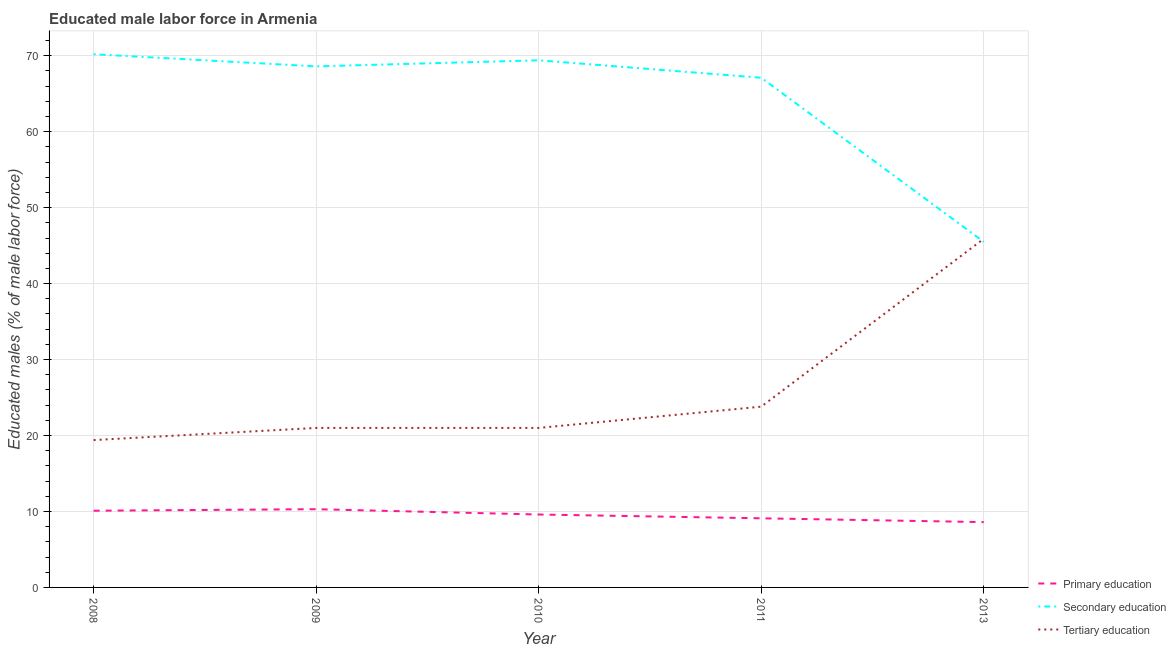What is the percentage of male labor force who received tertiary education in 2008?
Provide a short and direct response. 19.4. Across all years, what is the maximum percentage of male labor force who received tertiary education?
Keep it short and to the point. 45.9. Across all years, what is the minimum percentage of male labor force who received secondary education?
Keep it short and to the point. 45.5. What is the total percentage of male labor force who received tertiary education in the graph?
Give a very brief answer. 131.1. What is the difference between the percentage of male labor force who received secondary education in 2009 and that in 2013?
Your answer should be very brief. 23.1. What is the difference between the percentage of male labor force who received secondary education in 2010 and the percentage of male labor force who received tertiary education in 2009?
Offer a very short reply. 48.4. What is the average percentage of male labor force who received primary education per year?
Your response must be concise. 9.54. In the year 2010, what is the difference between the percentage of male labor force who received tertiary education and percentage of male labor force who received secondary education?
Your answer should be very brief. -48.4. In how many years, is the percentage of male labor force who received tertiary education greater than 16 %?
Ensure brevity in your answer.  5. What is the ratio of the percentage of male labor force who received tertiary education in 2008 to that in 2009?
Make the answer very short. 0.92. Is the percentage of male labor force who received secondary education in 2008 less than that in 2011?
Offer a terse response. No. What is the difference between the highest and the second highest percentage of male labor force who received primary education?
Ensure brevity in your answer.  0.2. What is the difference between the highest and the lowest percentage of male labor force who received secondary education?
Make the answer very short. 24.7. Is it the case that in every year, the sum of the percentage of male labor force who received primary education and percentage of male labor force who received secondary education is greater than the percentage of male labor force who received tertiary education?
Ensure brevity in your answer.  Yes. Does the percentage of male labor force who received tertiary education monotonically increase over the years?
Offer a terse response. No. What is the difference between two consecutive major ticks on the Y-axis?
Your response must be concise. 10. Are the values on the major ticks of Y-axis written in scientific E-notation?
Ensure brevity in your answer.  No. Where does the legend appear in the graph?
Offer a very short reply. Bottom right. How many legend labels are there?
Keep it short and to the point. 3. What is the title of the graph?
Make the answer very short. Educated male labor force in Armenia. Does "Central government" appear as one of the legend labels in the graph?
Your response must be concise. No. What is the label or title of the Y-axis?
Offer a terse response. Educated males (% of male labor force). What is the Educated males (% of male labor force) of Primary education in 2008?
Your answer should be very brief. 10.1. What is the Educated males (% of male labor force) in Secondary education in 2008?
Offer a terse response. 70.2. What is the Educated males (% of male labor force) of Tertiary education in 2008?
Ensure brevity in your answer.  19.4. What is the Educated males (% of male labor force) in Primary education in 2009?
Offer a very short reply. 10.3. What is the Educated males (% of male labor force) of Secondary education in 2009?
Make the answer very short. 68.6. What is the Educated males (% of male labor force) in Tertiary education in 2009?
Give a very brief answer. 21. What is the Educated males (% of male labor force) in Primary education in 2010?
Provide a short and direct response. 9.6. What is the Educated males (% of male labor force) in Secondary education in 2010?
Provide a succinct answer. 69.4. What is the Educated males (% of male labor force) in Primary education in 2011?
Your answer should be very brief. 9.1. What is the Educated males (% of male labor force) in Secondary education in 2011?
Provide a succinct answer. 67.1. What is the Educated males (% of male labor force) of Tertiary education in 2011?
Provide a short and direct response. 23.8. What is the Educated males (% of male labor force) of Primary education in 2013?
Provide a short and direct response. 8.6. What is the Educated males (% of male labor force) in Secondary education in 2013?
Keep it short and to the point. 45.5. What is the Educated males (% of male labor force) in Tertiary education in 2013?
Ensure brevity in your answer.  45.9. Across all years, what is the maximum Educated males (% of male labor force) in Primary education?
Make the answer very short. 10.3. Across all years, what is the maximum Educated males (% of male labor force) in Secondary education?
Keep it short and to the point. 70.2. Across all years, what is the maximum Educated males (% of male labor force) in Tertiary education?
Offer a very short reply. 45.9. Across all years, what is the minimum Educated males (% of male labor force) of Primary education?
Your answer should be compact. 8.6. Across all years, what is the minimum Educated males (% of male labor force) in Secondary education?
Offer a terse response. 45.5. Across all years, what is the minimum Educated males (% of male labor force) of Tertiary education?
Offer a terse response. 19.4. What is the total Educated males (% of male labor force) of Primary education in the graph?
Keep it short and to the point. 47.7. What is the total Educated males (% of male labor force) of Secondary education in the graph?
Ensure brevity in your answer.  320.8. What is the total Educated males (% of male labor force) in Tertiary education in the graph?
Offer a very short reply. 131.1. What is the difference between the Educated males (% of male labor force) in Secondary education in 2008 and that in 2010?
Keep it short and to the point. 0.8. What is the difference between the Educated males (% of male labor force) of Tertiary education in 2008 and that in 2010?
Make the answer very short. -1.6. What is the difference between the Educated males (% of male labor force) of Primary education in 2008 and that in 2011?
Your answer should be compact. 1. What is the difference between the Educated males (% of male labor force) in Secondary education in 2008 and that in 2011?
Make the answer very short. 3.1. What is the difference between the Educated males (% of male labor force) of Primary education in 2008 and that in 2013?
Your response must be concise. 1.5. What is the difference between the Educated males (% of male labor force) in Secondary education in 2008 and that in 2013?
Offer a terse response. 24.7. What is the difference between the Educated males (% of male labor force) in Tertiary education in 2008 and that in 2013?
Make the answer very short. -26.5. What is the difference between the Educated males (% of male labor force) in Primary education in 2009 and that in 2010?
Provide a short and direct response. 0.7. What is the difference between the Educated males (% of male labor force) in Secondary education in 2009 and that in 2010?
Offer a very short reply. -0.8. What is the difference between the Educated males (% of male labor force) in Primary education in 2009 and that in 2011?
Offer a terse response. 1.2. What is the difference between the Educated males (% of male labor force) of Secondary education in 2009 and that in 2011?
Provide a succinct answer. 1.5. What is the difference between the Educated males (% of male labor force) in Secondary education in 2009 and that in 2013?
Your answer should be very brief. 23.1. What is the difference between the Educated males (% of male labor force) of Tertiary education in 2009 and that in 2013?
Offer a terse response. -24.9. What is the difference between the Educated males (% of male labor force) in Primary education in 2010 and that in 2011?
Keep it short and to the point. 0.5. What is the difference between the Educated males (% of male labor force) in Primary education in 2010 and that in 2013?
Your response must be concise. 1. What is the difference between the Educated males (% of male labor force) of Secondary education in 2010 and that in 2013?
Your answer should be very brief. 23.9. What is the difference between the Educated males (% of male labor force) of Tertiary education in 2010 and that in 2013?
Offer a very short reply. -24.9. What is the difference between the Educated males (% of male labor force) in Primary education in 2011 and that in 2013?
Your answer should be very brief. 0.5. What is the difference between the Educated males (% of male labor force) of Secondary education in 2011 and that in 2013?
Provide a short and direct response. 21.6. What is the difference between the Educated males (% of male labor force) of Tertiary education in 2011 and that in 2013?
Offer a very short reply. -22.1. What is the difference between the Educated males (% of male labor force) of Primary education in 2008 and the Educated males (% of male labor force) of Secondary education in 2009?
Offer a very short reply. -58.5. What is the difference between the Educated males (% of male labor force) of Primary education in 2008 and the Educated males (% of male labor force) of Tertiary education in 2009?
Offer a very short reply. -10.9. What is the difference between the Educated males (% of male labor force) of Secondary education in 2008 and the Educated males (% of male labor force) of Tertiary education in 2009?
Keep it short and to the point. 49.2. What is the difference between the Educated males (% of male labor force) in Primary education in 2008 and the Educated males (% of male labor force) in Secondary education in 2010?
Offer a very short reply. -59.3. What is the difference between the Educated males (% of male labor force) in Primary education in 2008 and the Educated males (% of male labor force) in Tertiary education in 2010?
Provide a short and direct response. -10.9. What is the difference between the Educated males (% of male labor force) of Secondary education in 2008 and the Educated males (% of male labor force) of Tertiary education in 2010?
Your response must be concise. 49.2. What is the difference between the Educated males (% of male labor force) in Primary education in 2008 and the Educated males (% of male labor force) in Secondary education in 2011?
Make the answer very short. -57. What is the difference between the Educated males (% of male labor force) of Primary education in 2008 and the Educated males (% of male labor force) of Tertiary education in 2011?
Provide a short and direct response. -13.7. What is the difference between the Educated males (% of male labor force) of Secondary education in 2008 and the Educated males (% of male labor force) of Tertiary education in 2011?
Give a very brief answer. 46.4. What is the difference between the Educated males (% of male labor force) of Primary education in 2008 and the Educated males (% of male labor force) of Secondary education in 2013?
Offer a terse response. -35.4. What is the difference between the Educated males (% of male labor force) in Primary education in 2008 and the Educated males (% of male labor force) in Tertiary education in 2013?
Offer a terse response. -35.8. What is the difference between the Educated males (% of male labor force) of Secondary education in 2008 and the Educated males (% of male labor force) of Tertiary education in 2013?
Give a very brief answer. 24.3. What is the difference between the Educated males (% of male labor force) of Primary education in 2009 and the Educated males (% of male labor force) of Secondary education in 2010?
Offer a terse response. -59.1. What is the difference between the Educated males (% of male labor force) in Secondary education in 2009 and the Educated males (% of male labor force) in Tertiary education in 2010?
Your answer should be very brief. 47.6. What is the difference between the Educated males (% of male labor force) of Primary education in 2009 and the Educated males (% of male labor force) of Secondary education in 2011?
Your answer should be very brief. -56.8. What is the difference between the Educated males (% of male labor force) of Primary education in 2009 and the Educated males (% of male labor force) of Tertiary education in 2011?
Your answer should be compact. -13.5. What is the difference between the Educated males (% of male labor force) of Secondary education in 2009 and the Educated males (% of male labor force) of Tertiary education in 2011?
Offer a very short reply. 44.8. What is the difference between the Educated males (% of male labor force) of Primary education in 2009 and the Educated males (% of male labor force) of Secondary education in 2013?
Your response must be concise. -35.2. What is the difference between the Educated males (% of male labor force) of Primary education in 2009 and the Educated males (% of male labor force) of Tertiary education in 2013?
Make the answer very short. -35.6. What is the difference between the Educated males (% of male labor force) of Secondary education in 2009 and the Educated males (% of male labor force) of Tertiary education in 2013?
Give a very brief answer. 22.7. What is the difference between the Educated males (% of male labor force) in Primary education in 2010 and the Educated males (% of male labor force) in Secondary education in 2011?
Ensure brevity in your answer.  -57.5. What is the difference between the Educated males (% of male labor force) in Primary education in 2010 and the Educated males (% of male labor force) in Tertiary education in 2011?
Give a very brief answer. -14.2. What is the difference between the Educated males (% of male labor force) of Secondary education in 2010 and the Educated males (% of male labor force) of Tertiary education in 2011?
Give a very brief answer. 45.6. What is the difference between the Educated males (% of male labor force) of Primary education in 2010 and the Educated males (% of male labor force) of Secondary education in 2013?
Offer a very short reply. -35.9. What is the difference between the Educated males (% of male labor force) of Primary education in 2010 and the Educated males (% of male labor force) of Tertiary education in 2013?
Offer a very short reply. -36.3. What is the difference between the Educated males (% of male labor force) in Secondary education in 2010 and the Educated males (% of male labor force) in Tertiary education in 2013?
Your answer should be very brief. 23.5. What is the difference between the Educated males (% of male labor force) in Primary education in 2011 and the Educated males (% of male labor force) in Secondary education in 2013?
Ensure brevity in your answer.  -36.4. What is the difference between the Educated males (% of male labor force) of Primary education in 2011 and the Educated males (% of male labor force) of Tertiary education in 2013?
Keep it short and to the point. -36.8. What is the difference between the Educated males (% of male labor force) of Secondary education in 2011 and the Educated males (% of male labor force) of Tertiary education in 2013?
Your answer should be compact. 21.2. What is the average Educated males (% of male labor force) of Primary education per year?
Make the answer very short. 9.54. What is the average Educated males (% of male labor force) in Secondary education per year?
Give a very brief answer. 64.16. What is the average Educated males (% of male labor force) of Tertiary education per year?
Your response must be concise. 26.22. In the year 2008, what is the difference between the Educated males (% of male labor force) in Primary education and Educated males (% of male labor force) in Secondary education?
Offer a very short reply. -60.1. In the year 2008, what is the difference between the Educated males (% of male labor force) in Secondary education and Educated males (% of male labor force) in Tertiary education?
Your response must be concise. 50.8. In the year 2009, what is the difference between the Educated males (% of male labor force) of Primary education and Educated males (% of male labor force) of Secondary education?
Provide a short and direct response. -58.3. In the year 2009, what is the difference between the Educated males (% of male labor force) of Primary education and Educated males (% of male labor force) of Tertiary education?
Offer a very short reply. -10.7. In the year 2009, what is the difference between the Educated males (% of male labor force) of Secondary education and Educated males (% of male labor force) of Tertiary education?
Provide a succinct answer. 47.6. In the year 2010, what is the difference between the Educated males (% of male labor force) of Primary education and Educated males (% of male labor force) of Secondary education?
Offer a terse response. -59.8. In the year 2010, what is the difference between the Educated males (% of male labor force) in Secondary education and Educated males (% of male labor force) in Tertiary education?
Ensure brevity in your answer.  48.4. In the year 2011, what is the difference between the Educated males (% of male labor force) in Primary education and Educated males (% of male labor force) in Secondary education?
Provide a short and direct response. -58. In the year 2011, what is the difference between the Educated males (% of male labor force) of Primary education and Educated males (% of male labor force) of Tertiary education?
Your answer should be compact. -14.7. In the year 2011, what is the difference between the Educated males (% of male labor force) in Secondary education and Educated males (% of male labor force) in Tertiary education?
Make the answer very short. 43.3. In the year 2013, what is the difference between the Educated males (% of male labor force) in Primary education and Educated males (% of male labor force) in Secondary education?
Provide a succinct answer. -36.9. In the year 2013, what is the difference between the Educated males (% of male labor force) of Primary education and Educated males (% of male labor force) of Tertiary education?
Your answer should be compact. -37.3. In the year 2013, what is the difference between the Educated males (% of male labor force) of Secondary education and Educated males (% of male labor force) of Tertiary education?
Your answer should be compact. -0.4. What is the ratio of the Educated males (% of male labor force) in Primary education in 2008 to that in 2009?
Offer a very short reply. 0.98. What is the ratio of the Educated males (% of male labor force) in Secondary education in 2008 to that in 2009?
Ensure brevity in your answer.  1.02. What is the ratio of the Educated males (% of male labor force) in Tertiary education in 2008 to that in 2009?
Keep it short and to the point. 0.92. What is the ratio of the Educated males (% of male labor force) of Primary education in 2008 to that in 2010?
Provide a succinct answer. 1.05. What is the ratio of the Educated males (% of male labor force) of Secondary education in 2008 to that in 2010?
Give a very brief answer. 1.01. What is the ratio of the Educated males (% of male labor force) in Tertiary education in 2008 to that in 2010?
Ensure brevity in your answer.  0.92. What is the ratio of the Educated males (% of male labor force) in Primary education in 2008 to that in 2011?
Your response must be concise. 1.11. What is the ratio of the Educated males (% of male labor force) of Secondary education in 2008 to that in 2011?
Provide a succinct answer. 1.05. What is the ratio of the Educated males (% of male labor force) in Tertiary education in 2008 to that in 2011?
Keep it short and to the point. 0.82. What is the ratio of the Educated males (% of male labor force) in Primary education in 2008 to that in 2013?
Offer a very short reply. 1.17. What is the ratio of the Educated males (% of male labor force) of Secondary education in 2008 to that in 2013?
Keep it short and to the point. 1.54. What is the ratio of the Educated males (% of male labor force) of Tertiary education in 2008 to that in 2013?
Your answer should be very brief. 0.42. What is the ratio of the Educated males (% of male labor force) in Primary education in 2009 to that in 2010?
Ensure brevity in your answer.  1.07. What is the ratio of the Educated males (% of male labor force) in Secondary education in 2009 to that in 2010?
Make the answer very short. 0.99. What is the ratio of the Educated males (% of male labor force) in Tertiary education in 2009 to that in 2010?
Your answer should be very brief. 1. What is the ratio of the Educated males (% of male labor force) in Primary education in 2009 to that in 2011?
Provide a succinct answer. 1.13. What is the ratio of the Educated males (% of male labor force) in Secondary education in 2009 to that in 2011?
Provide a short and direct response. 1.02. What is the ratio of the Educated males (% of male labor force) of Tertiary education in 2009 to that in 2011?
Provide a succinct answer. 0.88. What is the ratio of the Educated males (% of male labor force) of Primary education in 2009 to that in 2013?
Give a very brief answer. 1.2. What is the ratio of the Educated males (% of male labor force) in Secondary education in 2009 to that in 2013?
Offer a very short reply. 1.51. What is the ratio of the Educated males (% of male labor force) of Tertiary education in 2009 to that in 2013?
Give a very brief answer. 0.46. What is the ratio of the Educated males (% of male labor force) in Primary education in 2010 to that in 2011?
Give a very brief answer. 1.05. What is the ratio of the Educated males (% of male labor force) in Secondary education in 2010 to that in 2011?
Provide a succinct answer. 1.03. What is the ratio of the Educated males (% of male labor force) in Tertiary education in 2010 to that in 2011?
Keep it short and to the point. 0.88. What is the ratio of the Educated males (% of male labor force) of Primary education in 2010 to that in 2013?
Ensure brevity in your answer.  1.12. What is the ratio of the Educated males (% of male labor force) in Secondary education in 2010 to that in 2013?
Give a very brief answer. 1.53. What is the ratio of the Educated males (% of male labor force) in Tertiary education in 2010 to that in 2013?
Provide a short and direct response. 0.46. What is the ratio of the Educated males (% of male labor force) in Primary education in 2011 to that in 2013?
Provide a short and direct response. 1.06. What is the ratio of the Educated males (% of male labor force) in Secondary education in 2011 to that in 2013?
Provide a short and direct response. 1.47. What is the ratio of the Educated males (% of male labor force) in Tertiary education in 2011 to that in 2013?
Offer a very short reply. 0.52. What is the difference between the highest and the second highest Educated males (% of male labor force) in Primary education?
Offer a very short reply. 0.2. What is the difference between the highest and the second highest Educated males (% of male labor force) in Secondary education?
Give a very brief answer. 0.8. What is the difference between the highest and the second highest Educated males (% of male labor force) in Tertiary education?
Keep it short and to the point. 22.1. What is the difference between the highest and the lowest Educated males (% of male labor force) of Secondary education?
Provide a succinct answer. 24.7. 